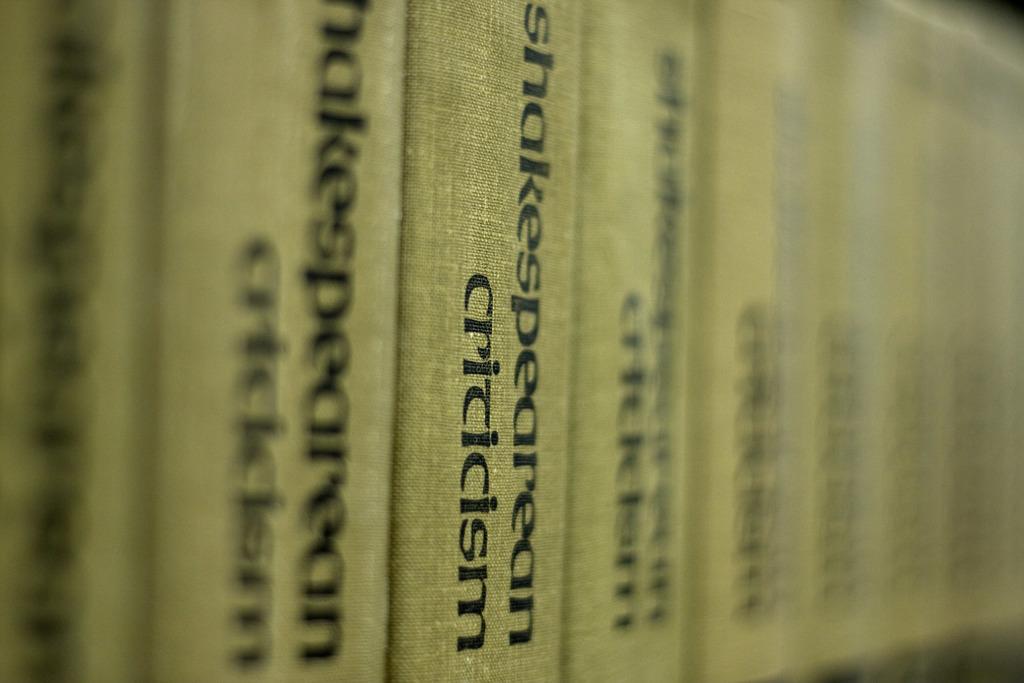What kind of criticism?
Ensure brevity in your answer.  Shakespearean. 